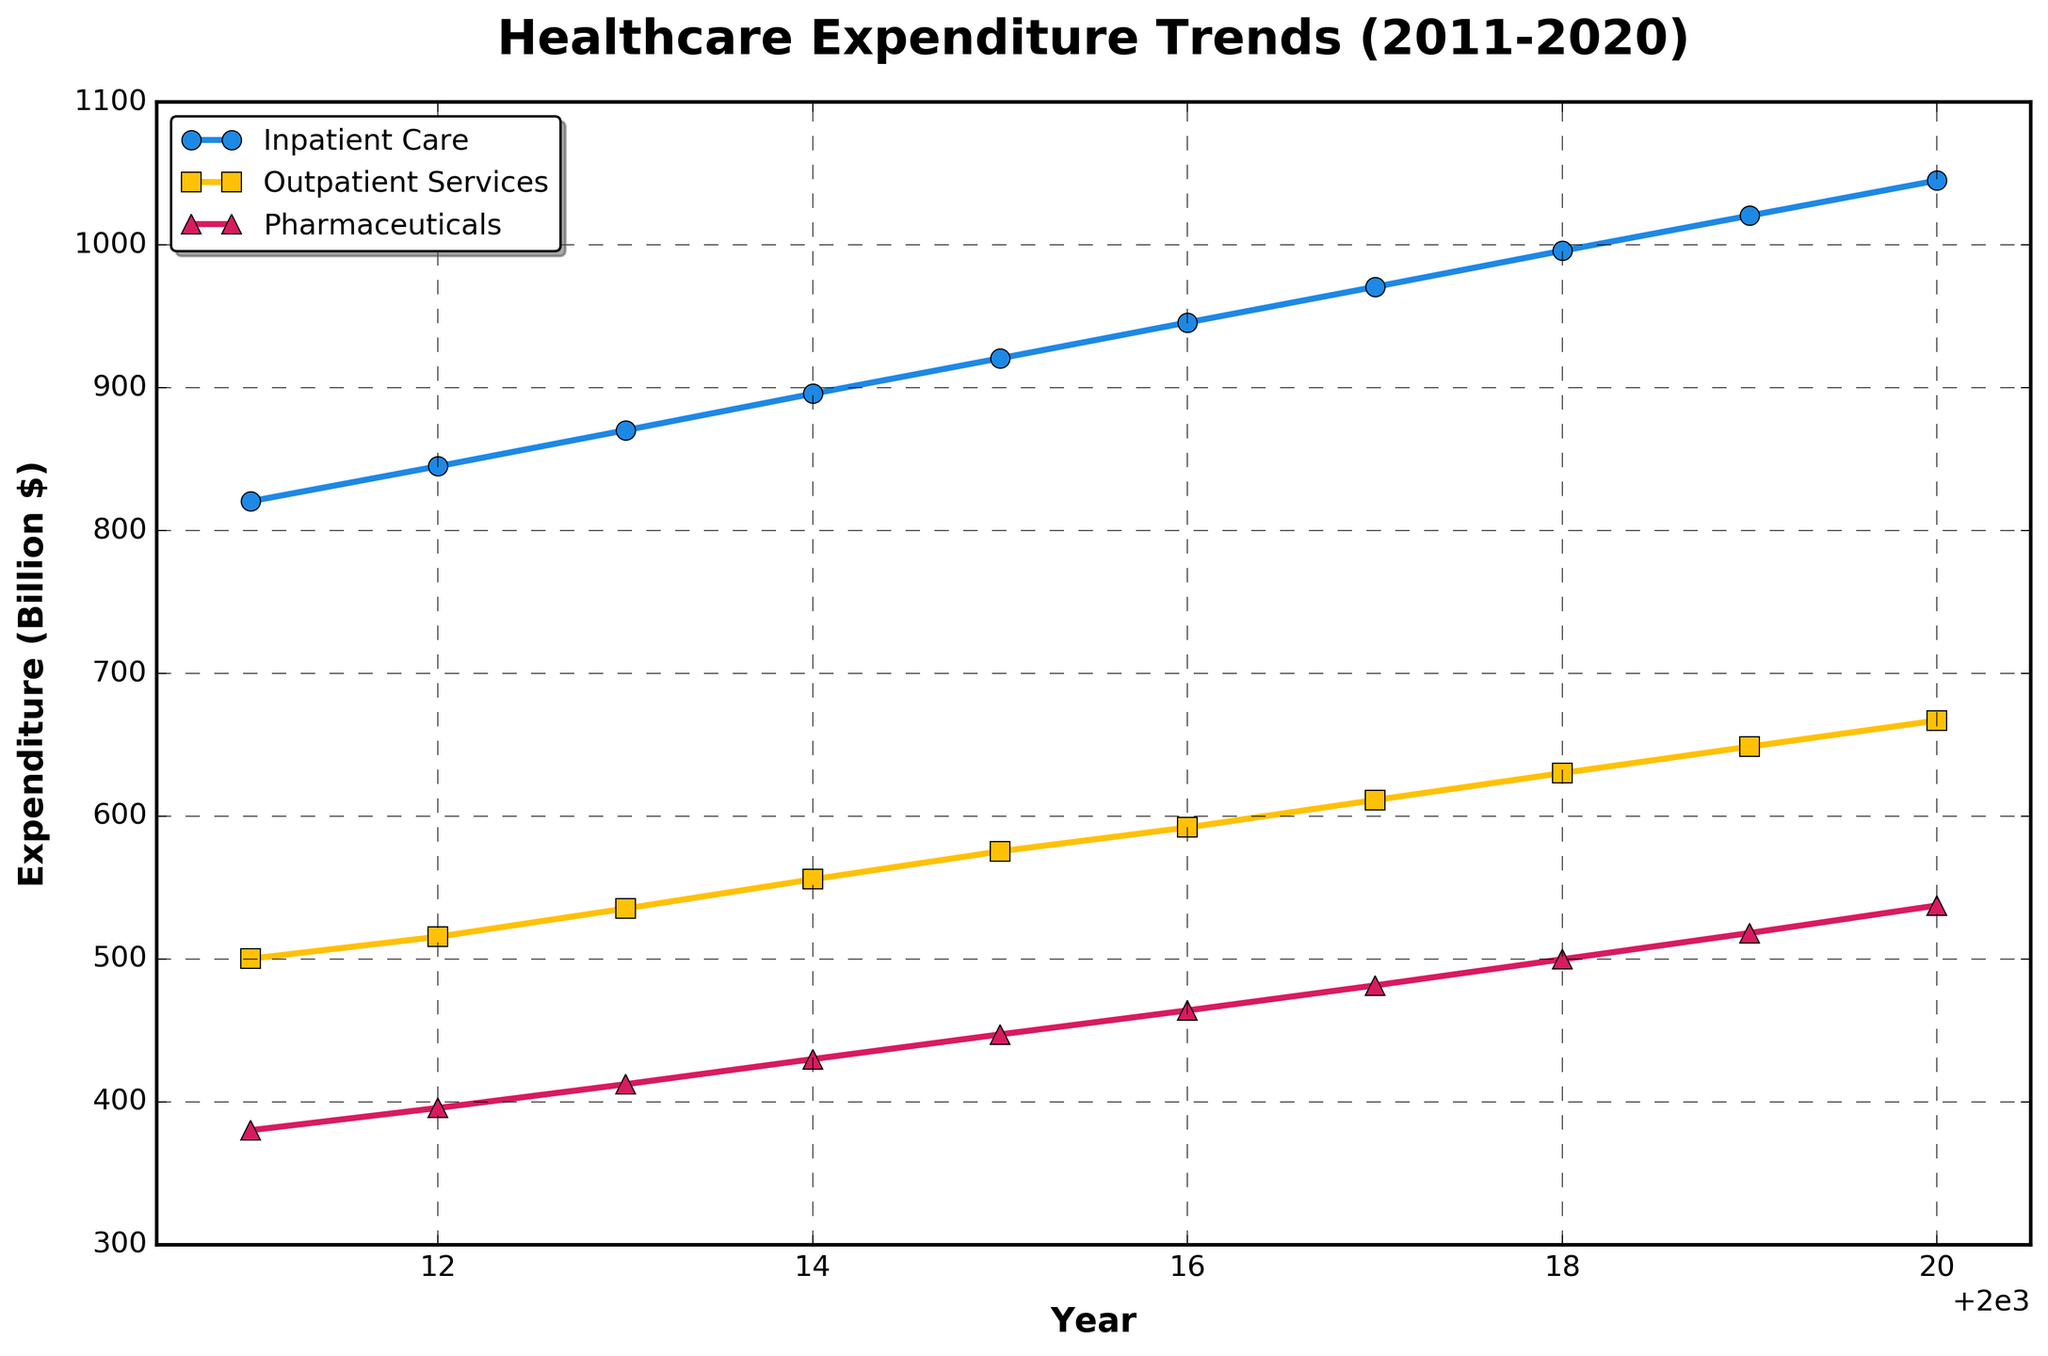what are the major categories shown in the plot? The plot shows three major categories of healthcare expenditure trends over the last decade. These categories are represented by separate lines with different markers and colors. The categories are Inpatient Care, Outpatient Services, and Pharmaceuticals.
Answer: Inpatient Care, Outpatient Services, Pharmaceuticals what is the expenditure trend for Inpatient Care in 2017? To find the expenditure trend for Inpatient Care in 2017, locate the year 2017 on the x-axis and follow the vertical line up to the Inpatient Care curve, which is marked with circles and colored blue. The corresponding y-axis value shows the expenditure. In 2017, the expenditure for Inpatient Care is around 970.6 Billion $.
Answer: 970.6 Billion $ which category shows the highest expenditure increase over the last decade? To determine which category shows the highest expenditure increase, compare the values at the start and end of the period (2011 and 2020) for each category. Inpatient Care increased from 820.5 Billion $ to 1045.1 Billion $, Outpatient Services from 500.2 Billion $ to 667.0 Billion $, and Pharmaceuticals from 380.1 Billion $ to 537.5 Billion $. Inpatient Care shows the highest increase, with a growth of 224.6 Billion $.
Answer: Inpatient Care how do the expenditures on Outpatient Services and Pharmaceuticals in 2020 compare? To compare the expenditures on Outpatient Services and Pharmaceuticals in 2020, locate the values for both categories in the year 2020 on the plot. Outpatient Services has an expenditure of 667.0 Billion $ while Pharmaceuticals has 537.5 Billion $. Outpatient Services has a higher expenditure compared to Pharmaceuticals in 2020.
Answer: Outpatient Services has a higher expenditure what is the average annual expenditure on Pharmaceuticals from 2011 to 2020? To calculate the average annual expenditure on Pharmaceuticals over the decade, sum the expenditure values for Pharmaceuticals across the years and divide by the number of years. The sum is (380.1+395.7+412.3+429.9+447.2+464.0+481.5+499.8+518.2+537.5) = 4566.2 Billion $. Dividing by 10 years gives an average of 456.62 Billion $ per year.
Answer: 456.62 Billion $ what year had the smallest expenditure gap between Outpatient Services and Pharmaceuticals? To find the year with the smallest expenditure gap between Outpatient Services and Pharmaceuticals, calculate the difference (gap) between the two categories for each year. The differences are: 2011 (120.1), 2012 (119.9), 2013 (123.0), 2014 (125.9), 2015 (128.2), 2016 (128.1), 2017 (129.8), 2018 (130.4), 2019 (130.5), and 2020 (129.5). The smallest gap is in 2012, with a difference of 119.9 Billion $.
Answer: 2012 which year did Inpatient Care exceed the 1000 Billion $ mark? To determine the year when Inpatient Care exceeded the 1000 Billion $ mark, follow the Inpatient Care line on the plot and identify the first year the value surpasses 1000 Billion $. This occurs in 2019 when the expenditure reaches 1020.5 Billion $.
Answer: 2019 